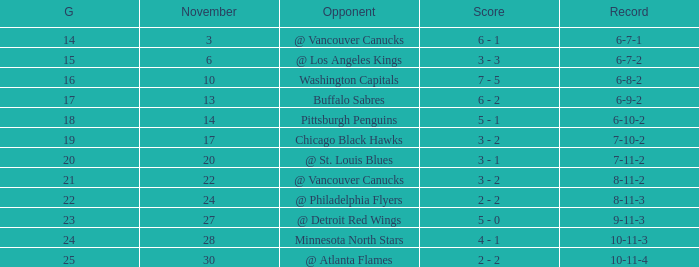What is the game when on november 27? 23.0. 